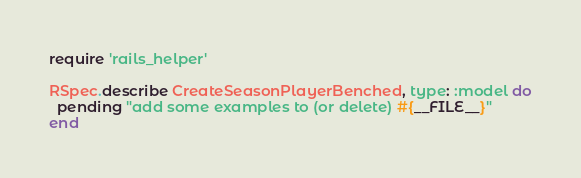Convert code to text. <code><loc_0><loc_0><loc_500><loc_500><_Ruby_>require 'rails_helper'

RSpec.describe CreateSeasonPlayerBenched, type: :model do
  pending "add some examples to (or delete) #{__FILE__}"
end
</code> 